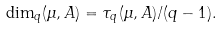Convert formula to latex. <formula><loc_0><loc_0><loc_500><loc_500>\dim _ { q } ( \mu , A ) = \tau _ { q } ( \mu , A ) / ( q - 1 ) .</formula> 